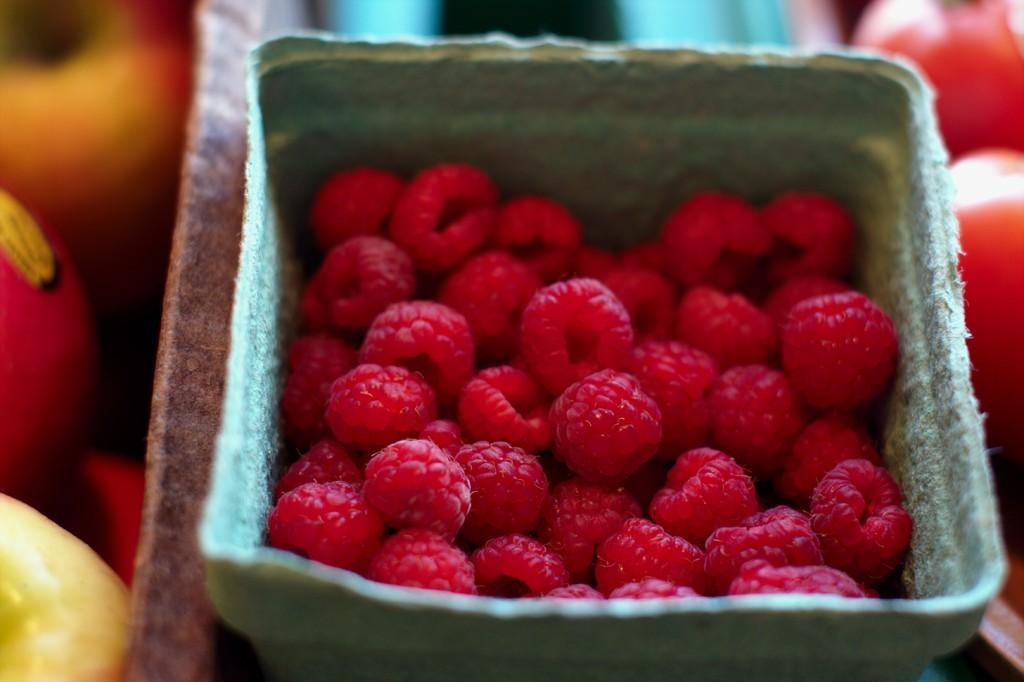How would you summarize this image in a sentence or two? This image consists of food which is in the center 